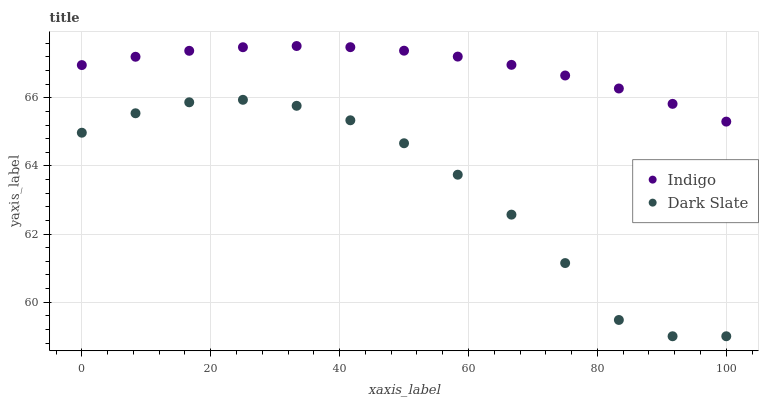Does Dark Slate have the minimum area under the curve?
Answer yes or no. Yes. Does Indigo have the maximum area under the curve?
Answer yes or no. Yes. Does Indigo have the minimum area under the curve?
Answer yes or no. No. Is Indigo the smoothest?
Answer yes or no. Yes. Is Dark Slate the roughest?
Answer yes or no. Yes. Is Indigo the roughest?
Answer yes or no. No. Does Dark Slate have the lowest value?
Answer yes or no. Yes. Does Indigo have the lowest value?
Answer yes or no. No. Does Indigo have the highest value?
Answer yes or no. Yes. Is Dark Slate less than Indigo?
Answer yes or no. Yes. Is Indigo greater than Dark Slate?
Answer yes or no. Yes. Does Dark Slate intersect Indigo?
Answer yes or no. No. 